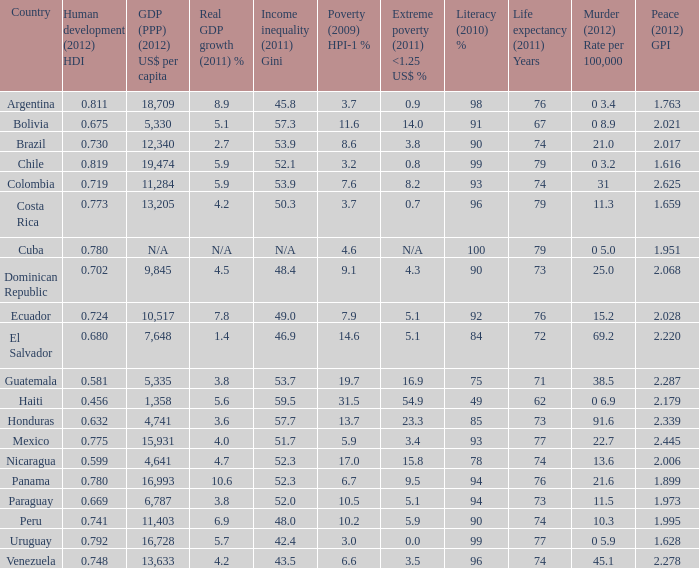616 as the harmony (2012) gpi? 0 3.2. 